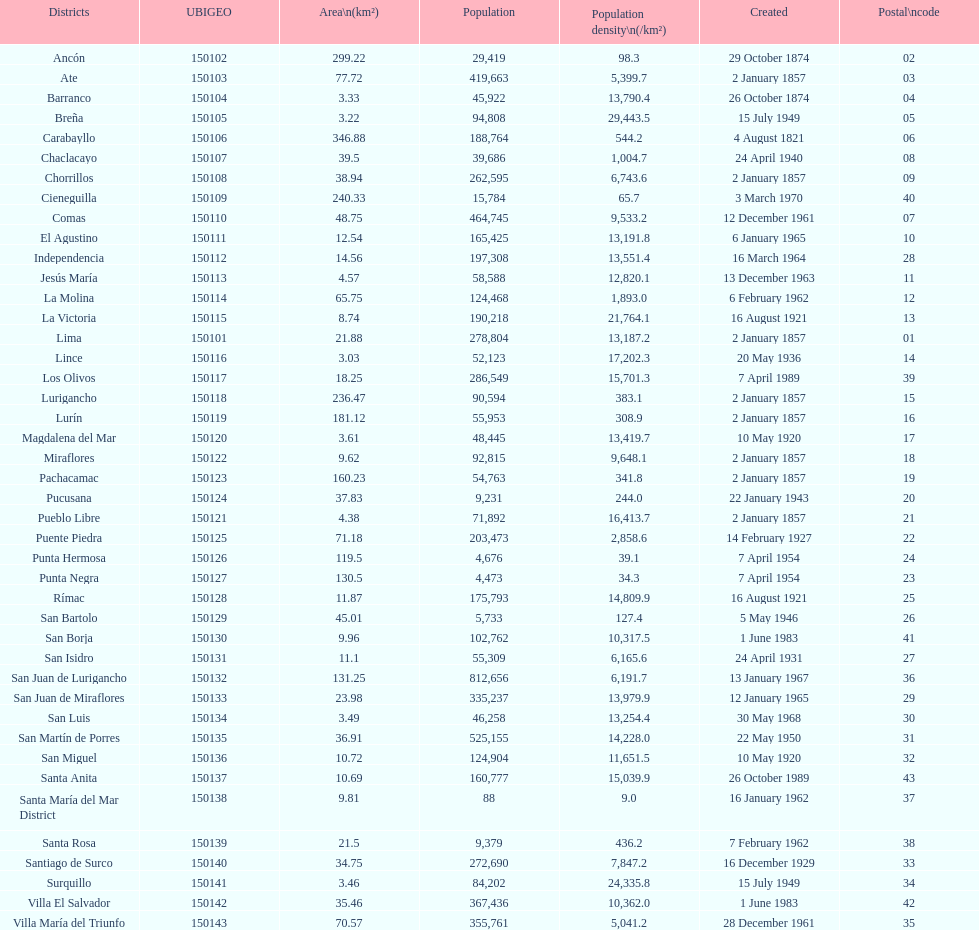In terms of population, what is the largest district? San Juan de Lurigancho. 